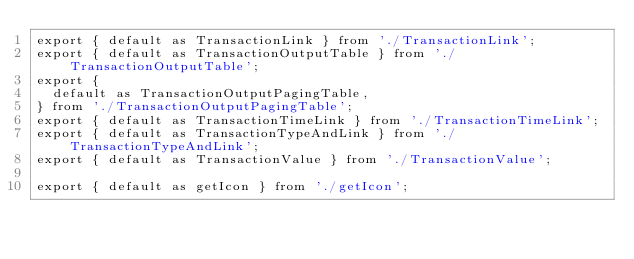Convert code to text. <code><loc_0><loc_0><loc_500><loc_500><_JavaScript_>export { default as TransactionLink } from './TransactionLink';
export { default as TransactionOutputTable } from './TransactionOutputTable';
export {
  default as TransactionOutputPagingTable,
} from './TransactionOutputPagingTable';
export { default as TransactionTimeLink } from './TransactionTimeLink';
export { default as TransactionTypeAndLink } from './TransactionTypeAndLink';
export { default as TransactionValue } from './TransactionValue';

export { default as getIcon } from './getIcon';
</code> 